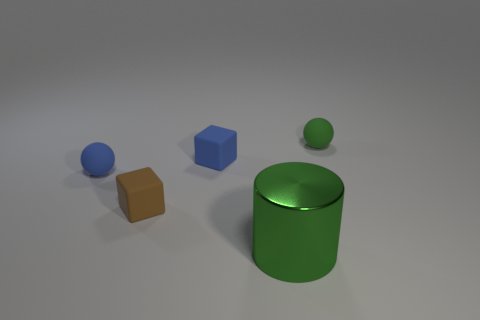Add 2 big rubber cubes. How many objects exist? 7 Subtract all balls. How many objects are left? 3 Subtract 0 blue cylinders. How many objects are left? 5 Subtract all green cylinders. Subtract all blue spheres. How many objects are left? 3 Add 2 blue cubes. How many blue cubes are left? 3 Add 4 small blue blocks. How many small blue blocks exist? 5 